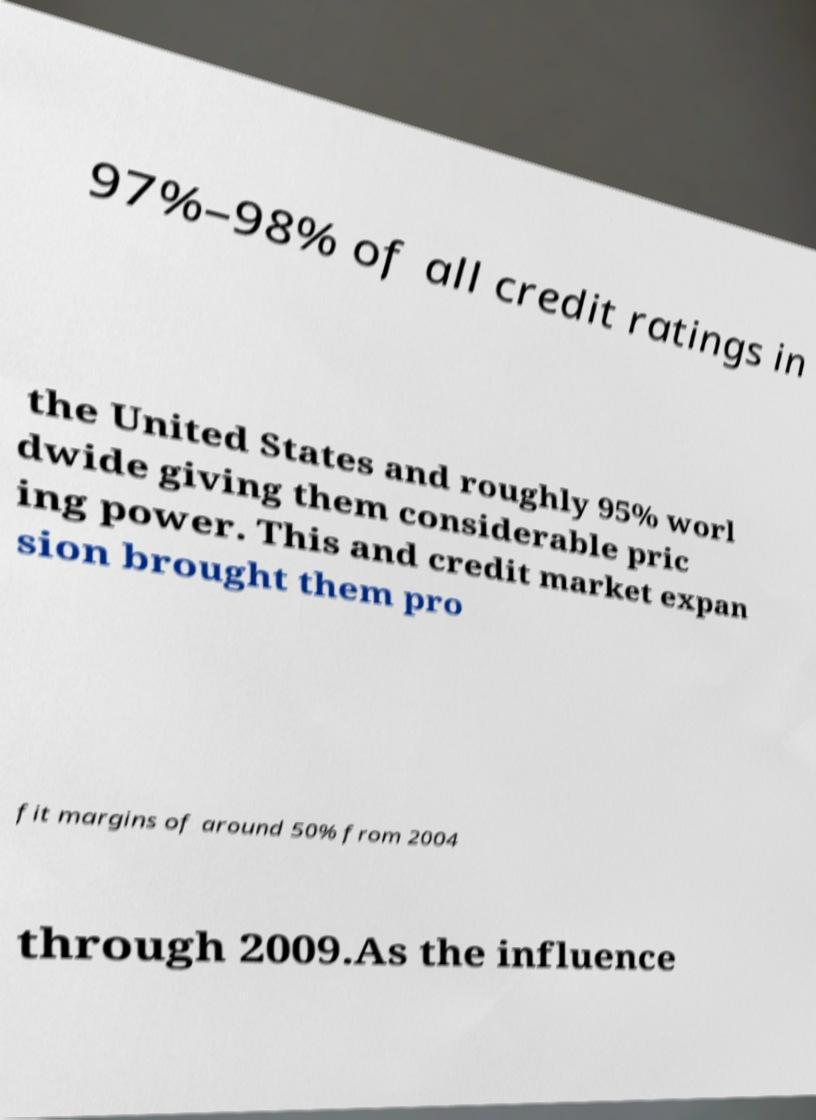What messages or text are displayed in this image? I need them in a readable, typed format. 97%–98% of all credit ratings in the United States and roughly 95% worl dwide giving them considerable pric ing power. This and credit market expan sion brought them pro fit margins of around 50% from 2004 through 2009.As the influence 